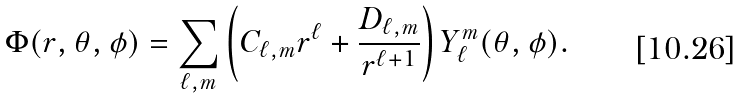<formula> <loc_0><loc_0><loc_500><loc_500>\Phi ( r , \theta , \phi ) = \sum _ { \ell , m } \left ( C _ { \ell , m } r ^ { \ell } + \frac { D _ { \ell , m } } { r ^ { \ell + 1 } } \right ) Y _ { \ell } ^ { m } ( \theta , \phi ) .</formula> 